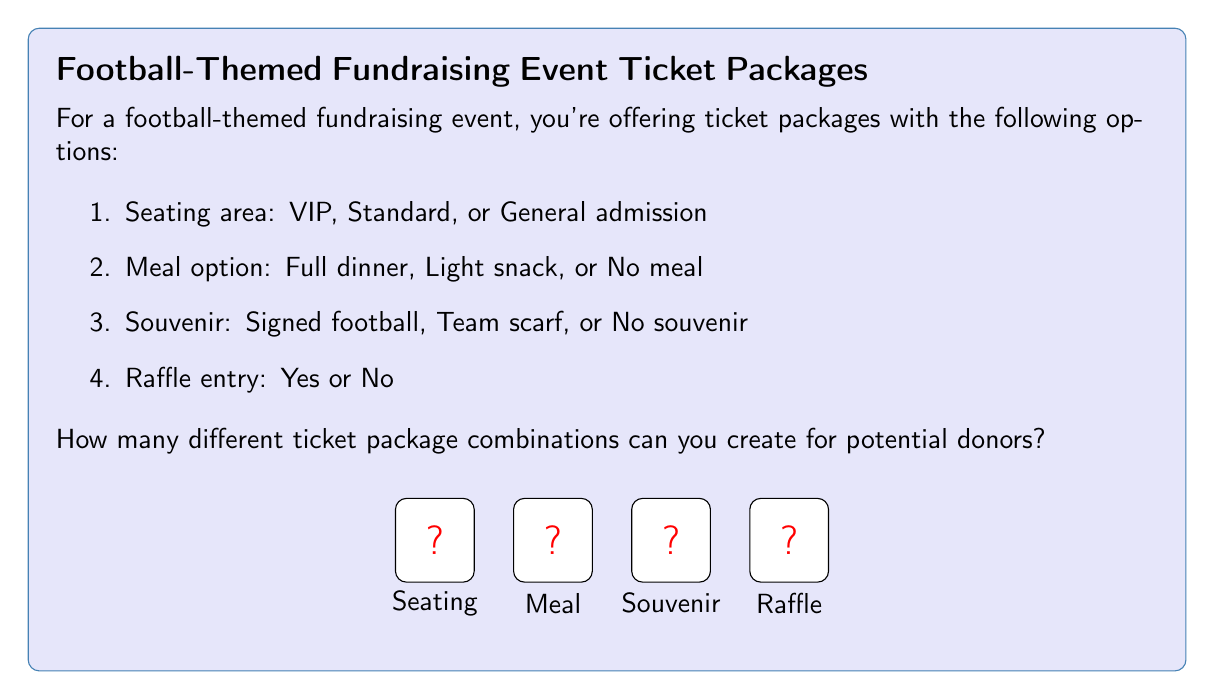Show me your answer to this math problem. To solve this problem, we'll use the multiplication principle of counting. This principle states that if we have a series of independent choices, the total number of possibilities is the product of the number of options for each choice.

Let's break down the choices:

1. Seating area: 3 options (VIP, Standard, General admission)
2. Meal option: 3 options (Full dinner, Light snack, No meal)
3. Souvenir: 3 options (Signed football, Team scarf, No souvenir)
4. Raffle entry: 2 options (Yes, No)

Now, we multiply the number of options for each choice:

$$ \text{Total combinations} = 3 \times 3 \times 3 \times 2 $$

Calculating this:
$$ 3 \times 3 \times 3 \times 2 = 27 \times 2 = 54 $$

Therefore, there are 54 different ticket package combinations that can be created for potential donors.

This calculation ensures that every possible combination of choices is accounted for, from a VIP seat with full dinner, signed football, and raffle entry, to a general admission seat with no meal, no souvenir, and no raffle entry, and everything in between.
Answer: 54 combinations 